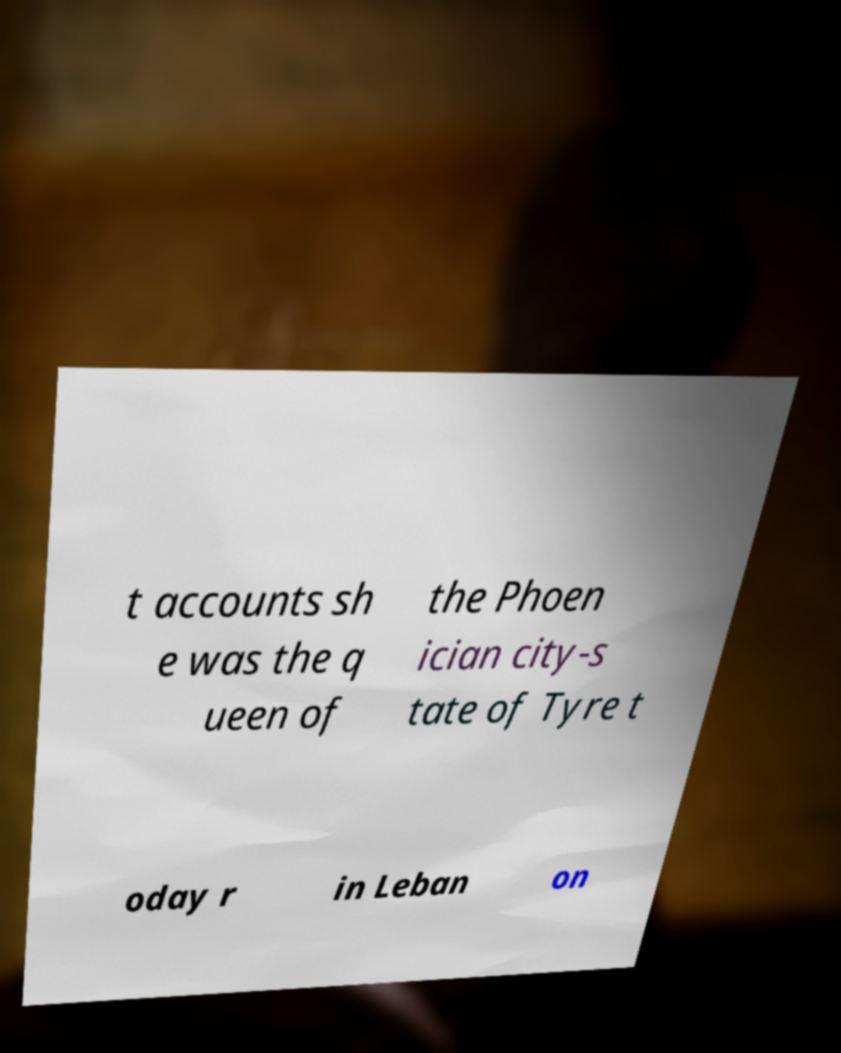Could you assist in decoding the text presented in this image and type it out clearly? t accounts sh e was the q ueen of the Phoen ician city-s tate of Tyre t oday r in Leban on 